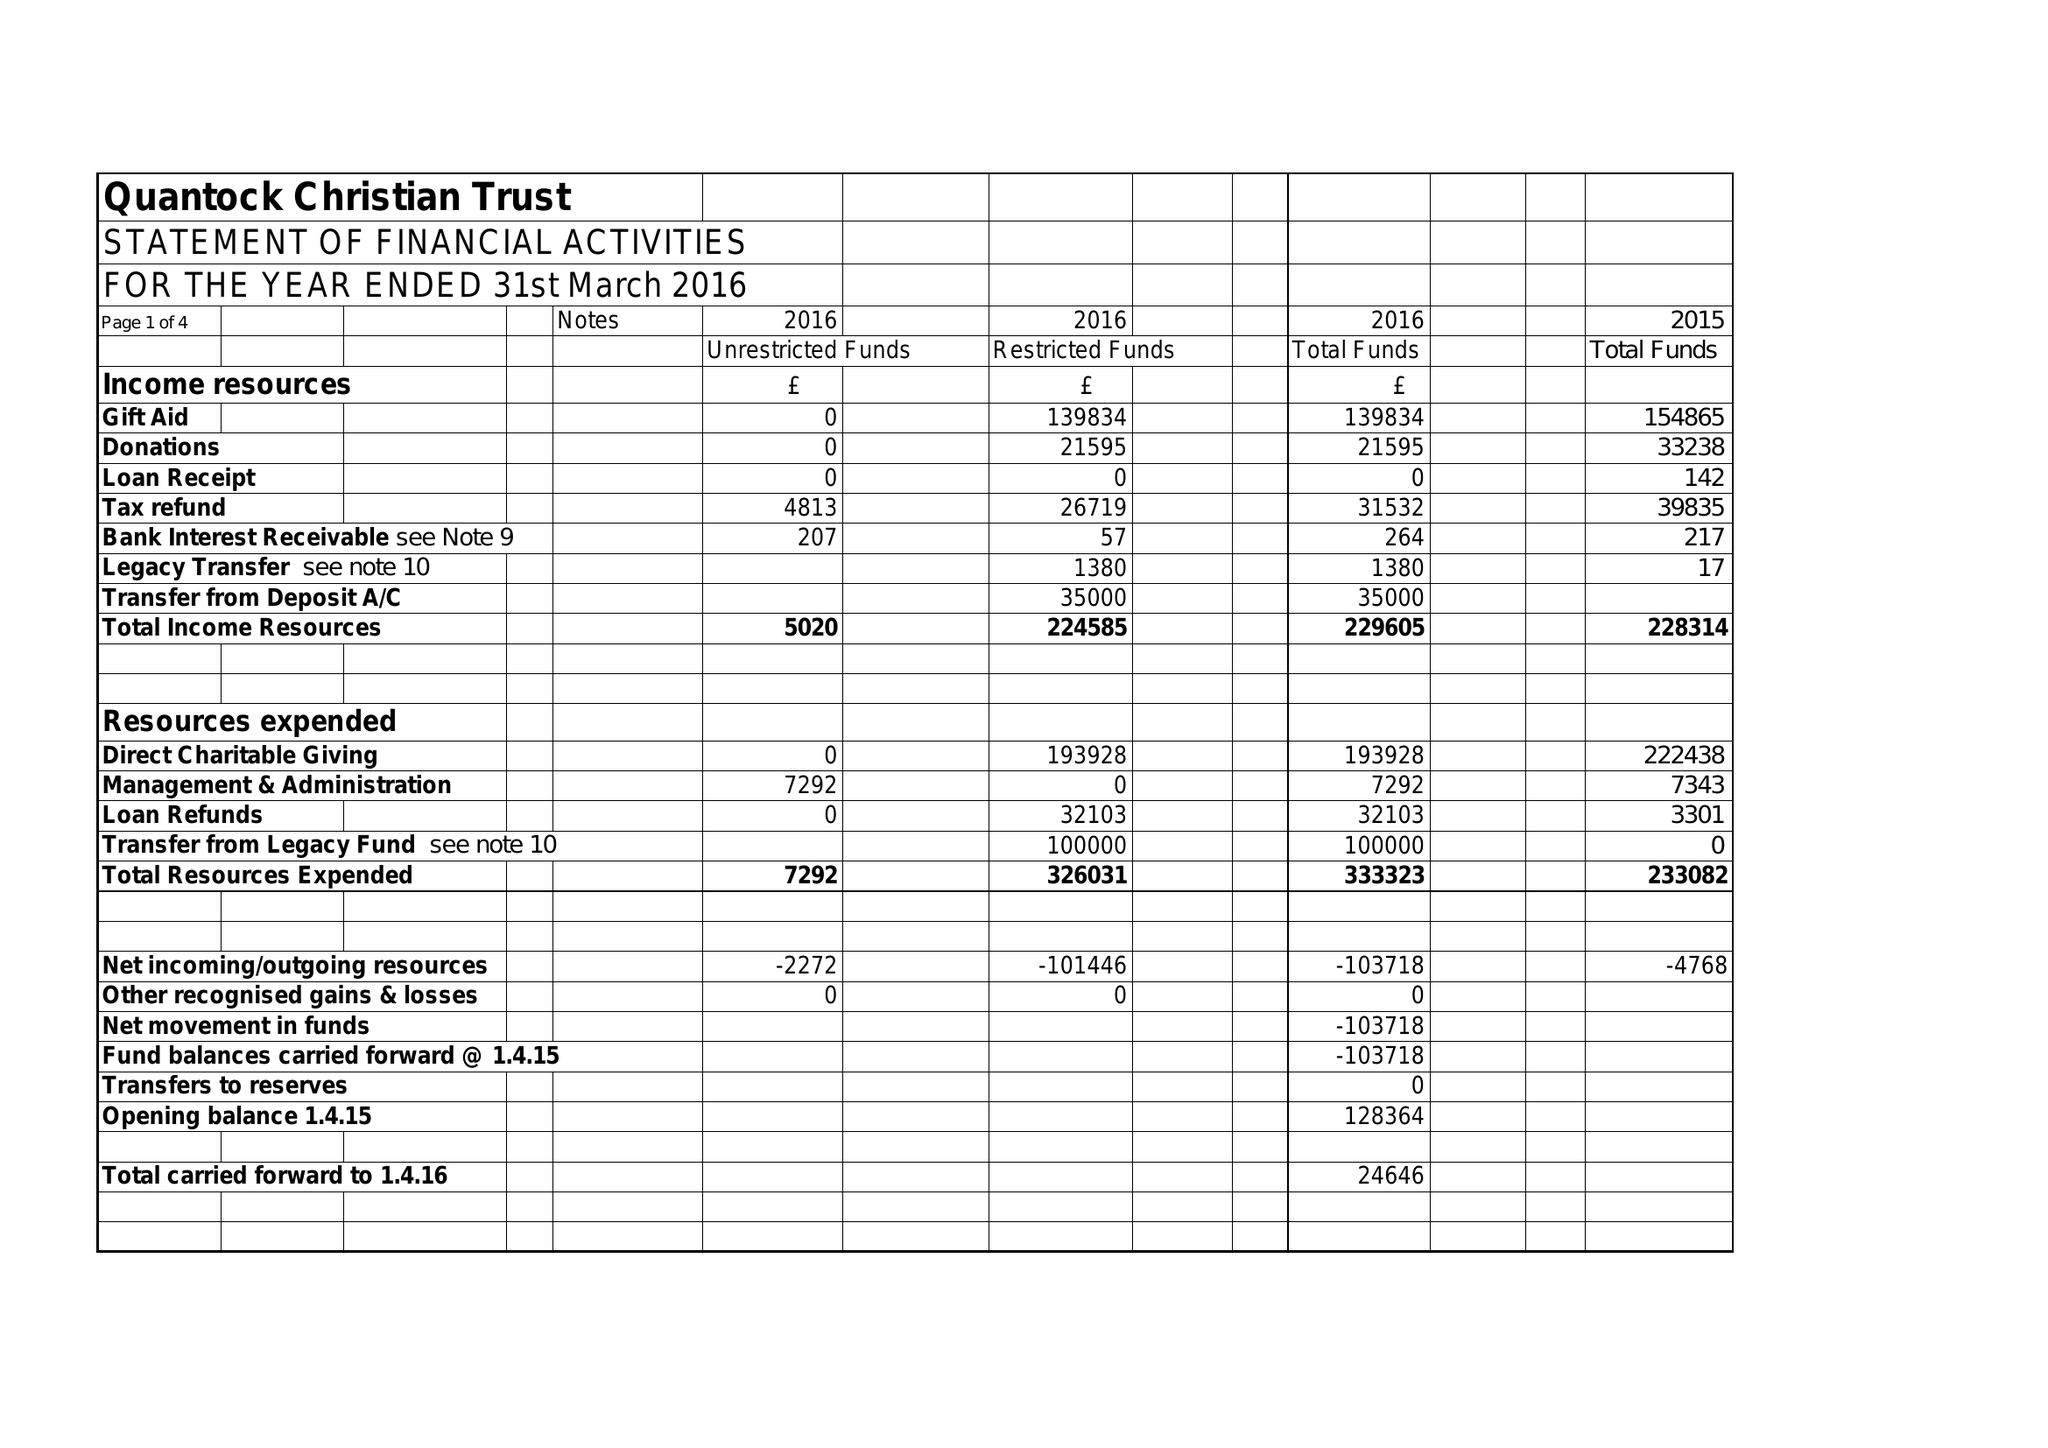What is the value for the address__post_town?
Answer the question using a single word or phrase. BRIDGWATER 